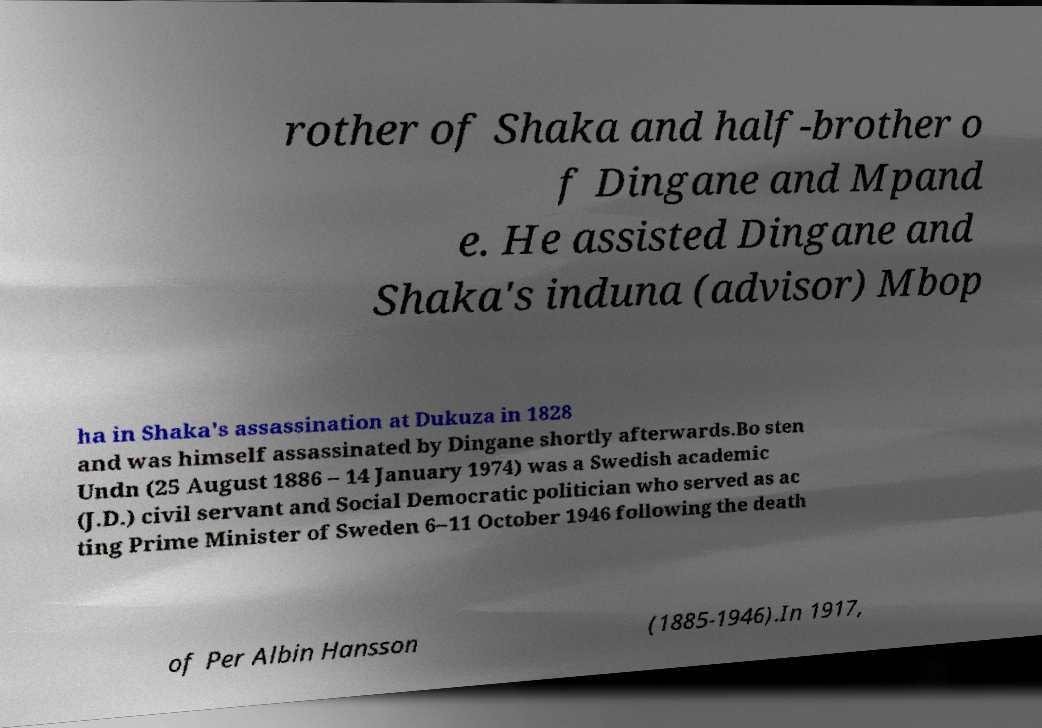Can you accurately transcribe the text from the provided image for me? rother of Shaka and half-brother o f Dingane and Mpand e. He assisted Dingane and Shaka's induna (advisor) Mbop ha in Shaka's assassination at Dukuza in 1828 and was himself assassinated by Dingane shortly afterwards.Bo sten Undn (25 August 1886 – 14 January 1974) was a Swedish academic (J.D.) civil servant and Social Democratic politician who served as ac ting Prime Minister of Sweden 6–11 October 1946 following the death of Per Albin Hansson (1885-1946).In 1917, 